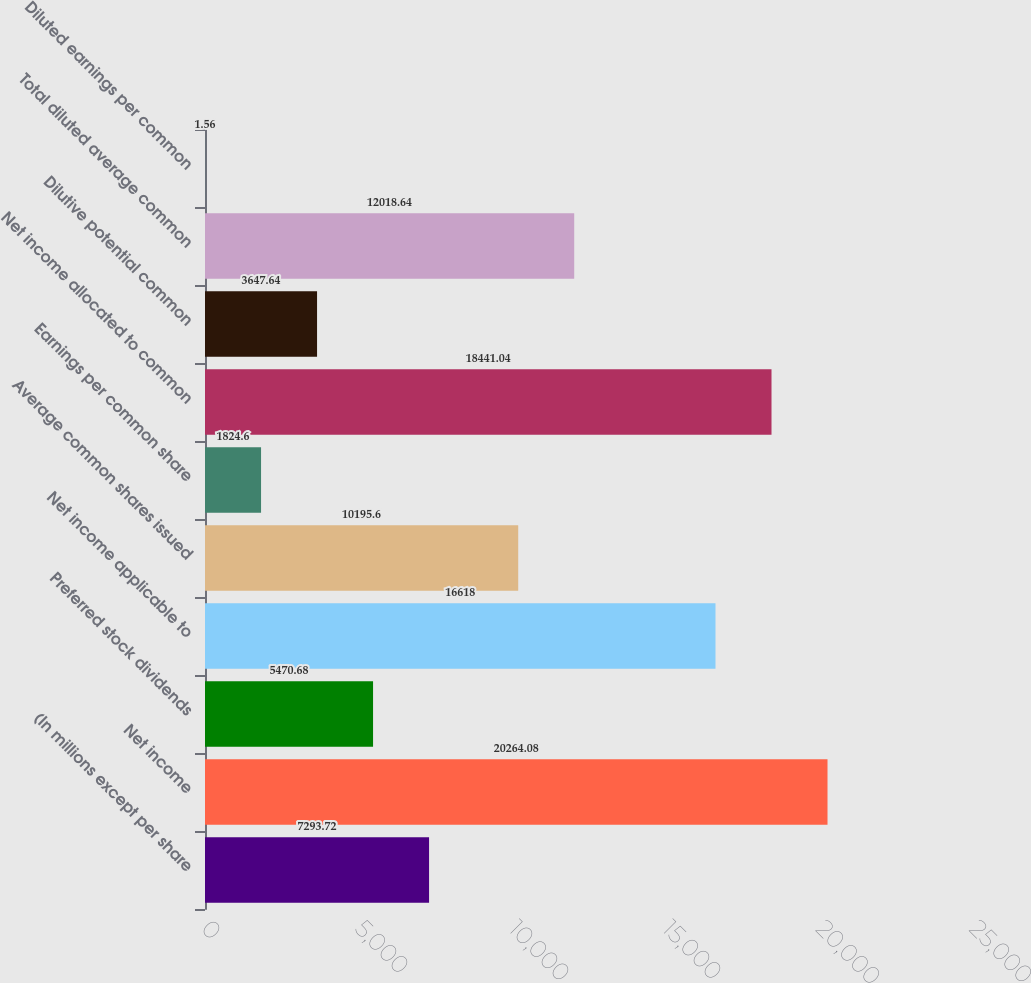Convert chart. <chart><loc_0><loc_0><loc_500><loc_500><bar_chart><fcel>(In millions except per share<fcel>Net income<fcel>Preferred stock dividends<fcel>Net income applicable to<fcel>Average common shares issued<fcel>Earnings per common share<fcel>Net income allocated to common<fcel>Dilutive potential common<fcel>Total diluted average common<fcel>Diluted earnings per common<nl><fcel>7293.72<fcel>20264.1<fcel>5470.68<fcel>16618<fcel>10195.6<fcel>1824.6<fcel>18441<fcel>3647.64<fcel>12018.6<fcel>1.56<nl></chart> 